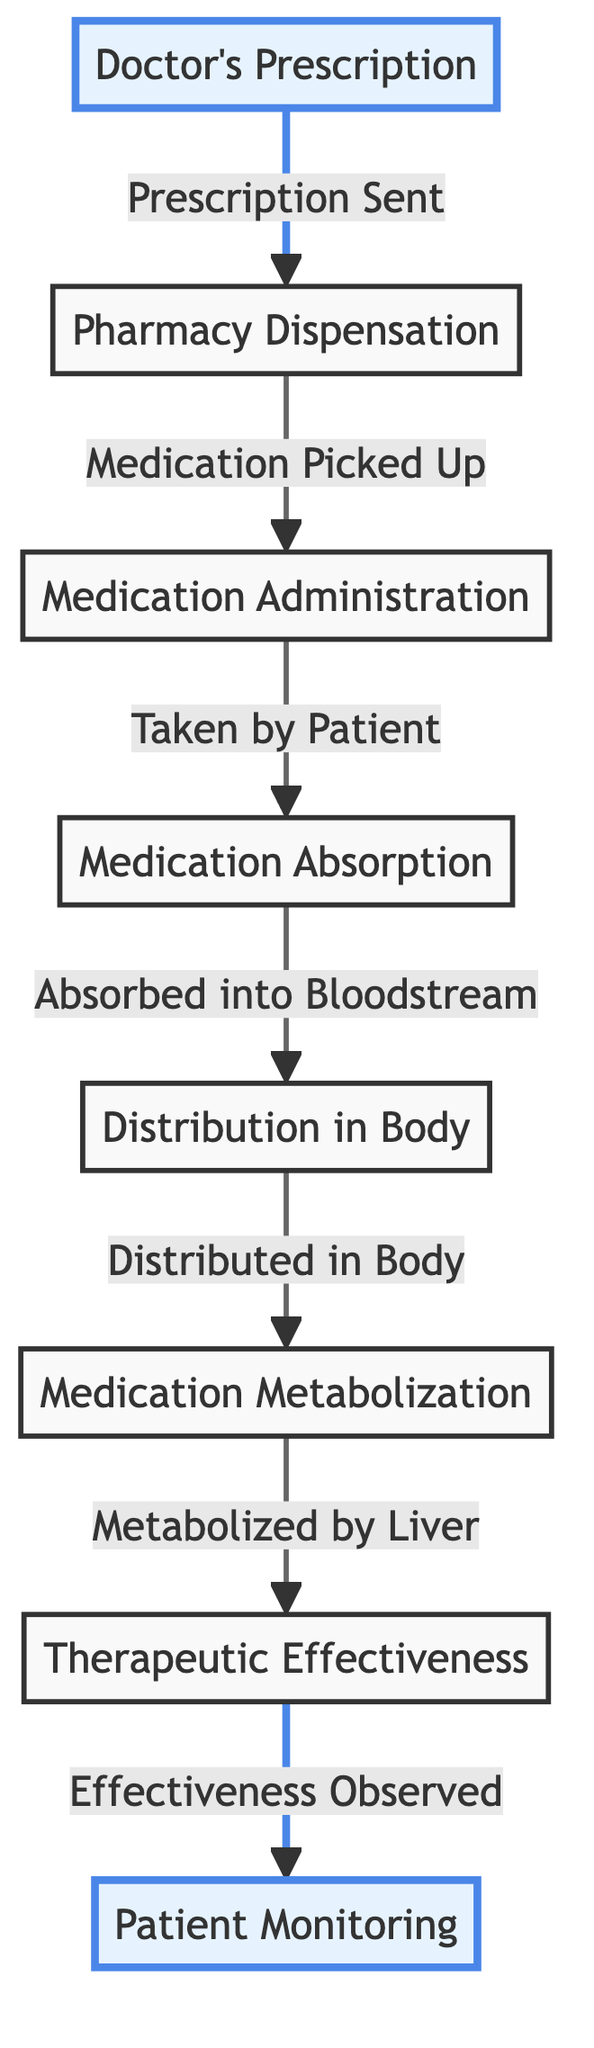What is the first step in the medication journey? The first step in the medication journey is the doctor's prescription. This is visually shown as the starting node in the diagram.
Answer: Doctor's Prescription How many total nodes are present in the diagram? Counting each unique step in the flow, there are seven nodes: Doctor's Prescription, Pharmacy Dispensation, Medication Administration, Medication Absorption, Distribution in Body, Medication Metabolization, and Therapeutic Effectiveness. Therefore, the total number of nodes is seven.
Answer: 7 What does the second step represent? The second step is Pharmacy Dispensation, which indicates the process where the prescription is filled by the pharmacy after being sent from the doctor. This is directly following the doctor's prescription in the flow.
Answer: Pharmacy Dispensation Which node follows Medication Absorption? After Medication Absorption, the next step in the diagram is Distribution in Body. This shows the sequential flow of medication once it has been absorbed into the bloodstream.
Answer: Distribution in Body Which node is highlighted in the diagram? The nodes that are highlighted in the diagram are the Doctor's Prescription and Patient Monitoring. The highlighting denotes their importance or significance in the overall process.
Answer: Doctor's Prescription, Patient Monitoring What happens after Medication Metabolization? Following Medication Metabolization, the medication reaches the node Therapeutic Effectiveness, indicating that it is evaluated for its effectiveness after being processed by the liver.
Answer: Therapeutic Effectiveness How many connections are there in total between the nodes? The connections in the diagram flow from one node to the next in a chain. Counting each arrow between pairs of nodes shows there are six connections in total.
Answer: 6 What main process does the Medication Administration node represent? The Medication Administration node represents the action of the patient taking the medication prescribed by the doctor, marking an essential step in the medication journey.
Answer: Taken by Patient After observing effectiveness, what is the final step mentioned in the diagram? The final step mentioned after observing effectiveness in the process is Patient Monitoring, which indicates a follow-up on the medication's response and overall health of the patient.
Answer: Patient Monitoring 